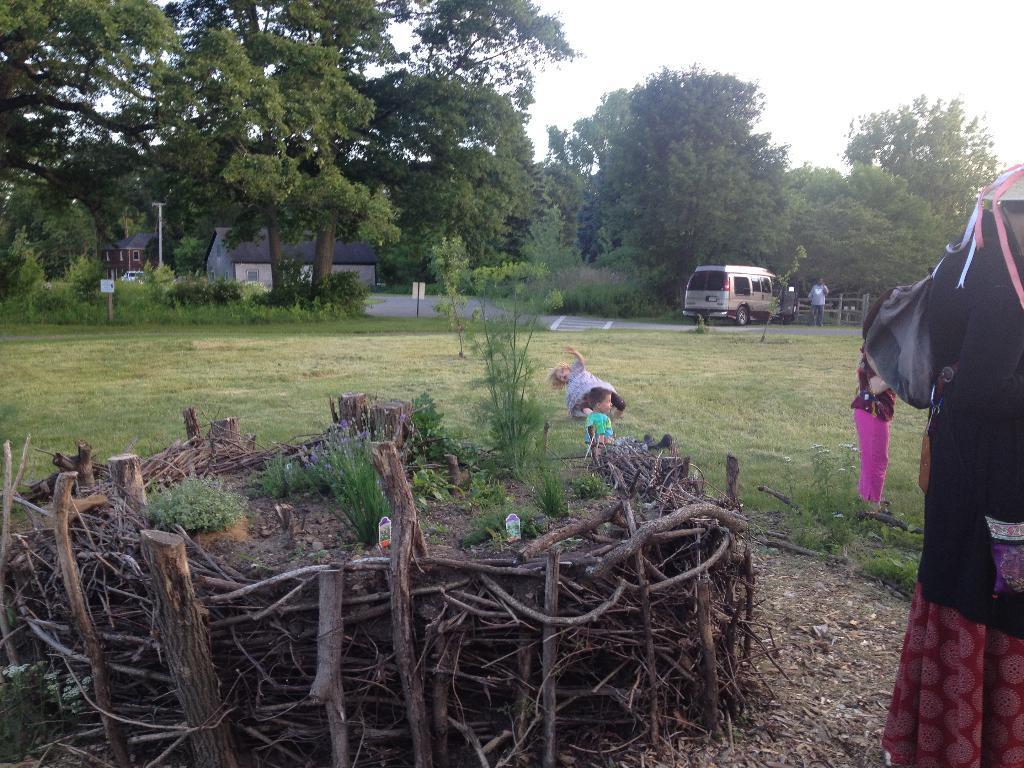Can you describe this image briefly? In this picture I can see a woman on the right and in front I can see number of wooden sticks. In the middle of this picture I can see the grass on which there are 2 children. In the background I can see the plants, number of trees, few buildings, a vehicle, a person and the sky. 